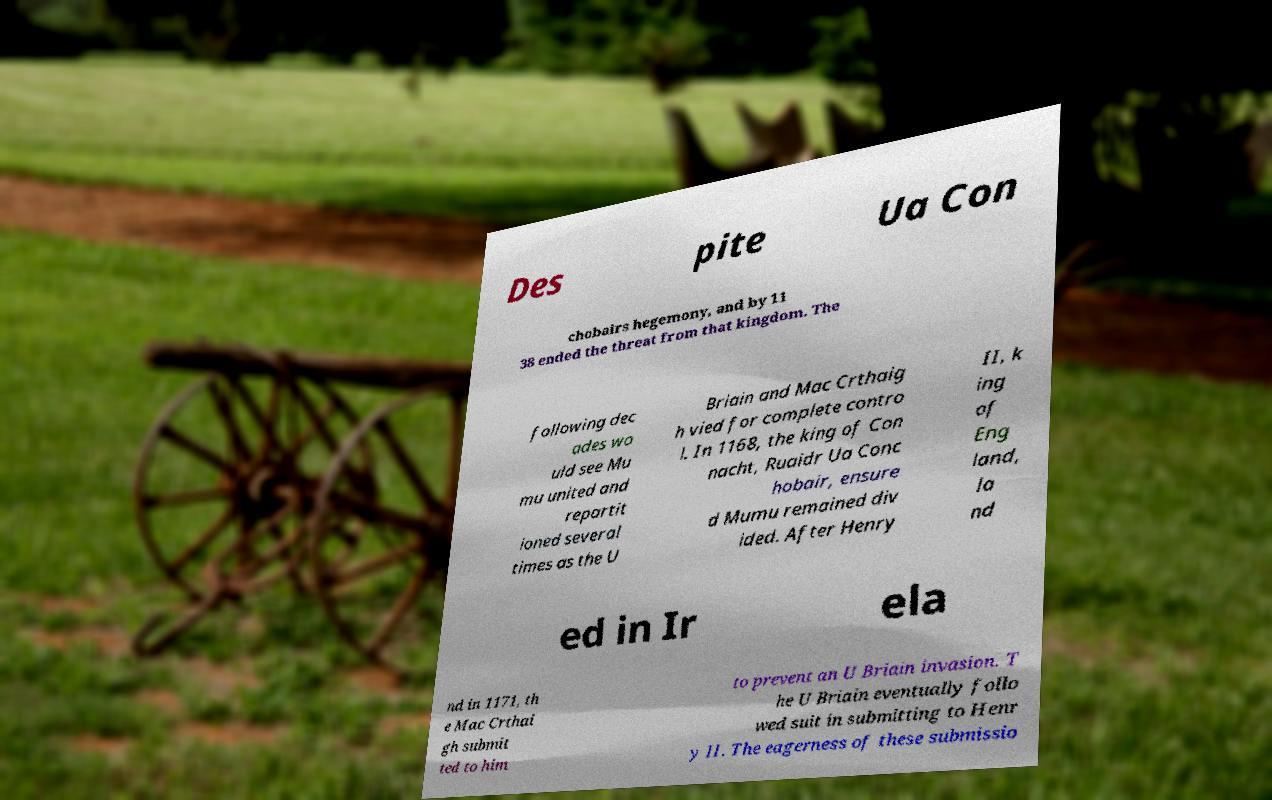Could you assist in decoding the text presented in this image and type it out clearly? Des pite Ua Con chobairs hegemony, and by 11 38 ended the threat from that kingdom. The following dec ades wo uld see Mu mu united and repartit ioned several times as the U Briain and Mac Crthaig h vied for complete contro l. In 1168, the king of Con nacht, Ruaidr Ua Conc hobair, ensure d Mumu remained div ided. After Henry II, k ing of Eng land, la nd ed in Ir ela nd in 1171, th e Mac Crthai gh submit ted to him to prevent an U Briain invasion. T he U Briain eventually follo wed suit in submitting to Henr y II. The eagerness of these submissio 